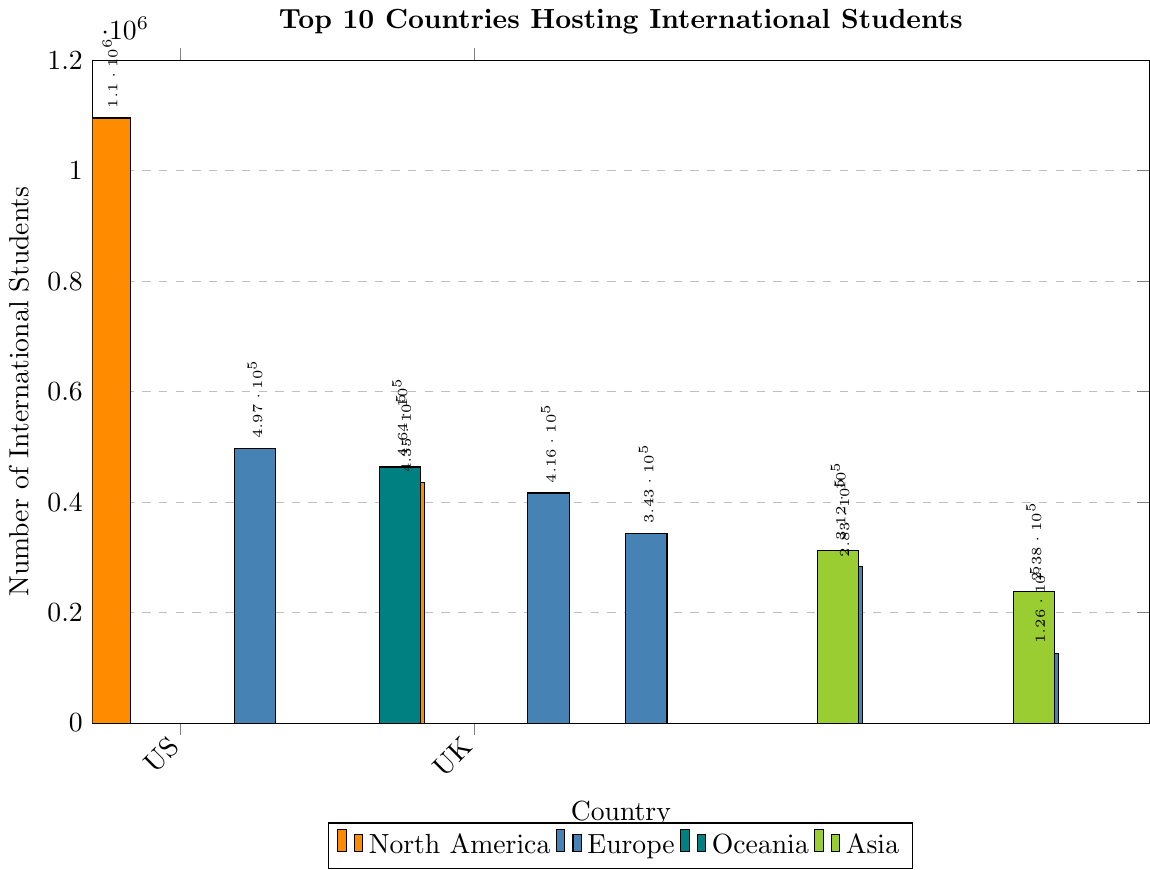Which country hosts the most international students? The country with the tallest bar represents the highest number of international students. In the figure, the United States has the tallest bar.
Answer: United States Which continent has the highest total number of international students? Sum the number of international students for each country within the same continent and compare the sums. North America (US and Canada) has 1,091,299 + 435,415 = 1,529,714; Europe (UK, Germany, France, Russia, Spain) has 496,570 + 416,437 + 343,386 + 282,921 + 125,675 = 1,665,989; Oceania (Australia) has 463,643; Asia (Japan and China) has 312,214 + 238,184 = 550,398. Europe has the highest total.
Answer: Europe Which country in Asia hosts more international students, Japan or China? Compare the height of the bars for Japan and China. The bar for Japan is taller.
Answer: Japan How many more international students does the United States host compared to the United Kingdom? Subtract the number of international students in the United Kingdom from the number in the United States. 1,095,299 (United States) - 496,570 (United Kingdom) = 598,729 more students.
Answer: 598,729 What is the difference between the number of international students in Canada and Australia? Subtract the number of students in Australia from the number in Canada. 435,415 (Canada) - 463,643 (Australia) = -28,228.
Answer: 28,228 (Australia has more) Which continent has the smallest representation in the top 10 countries hosting international students? Compare the number of countries from each continent represented in the top 10. Oceania has only 1 country (Australia).
Answer: Oceania Which country has the smallest number of international students in the top 10 list? The bar with the shortest height corresponds to the country with the smallest number of international students, which is Spain.
Answer: Spain On which three continents are the top 10 countries hosting international students located? Identify the continents listed in the legend of the figure. The continents shown are North America, Europe, Oceania, and Asia. Excluding repeated continents, the top 10 countries are in North America, Europe, and Oceania.
Answer: North America, Europe, Oceania What is the average number of international students hosted by the European countries in the top 10? Sum the number of international students in the European countries and divide by the number of such countries. The European countries in the top 10 are the UK (496,570), Germany (416,437), France (343,386), Russia (282,921), and Spain (125,675). The sum is 1,665,989. Divide this by 5, the number of European countries: 1,665,989 / 5 = 333,197.8.
Answer: 333,197.8 